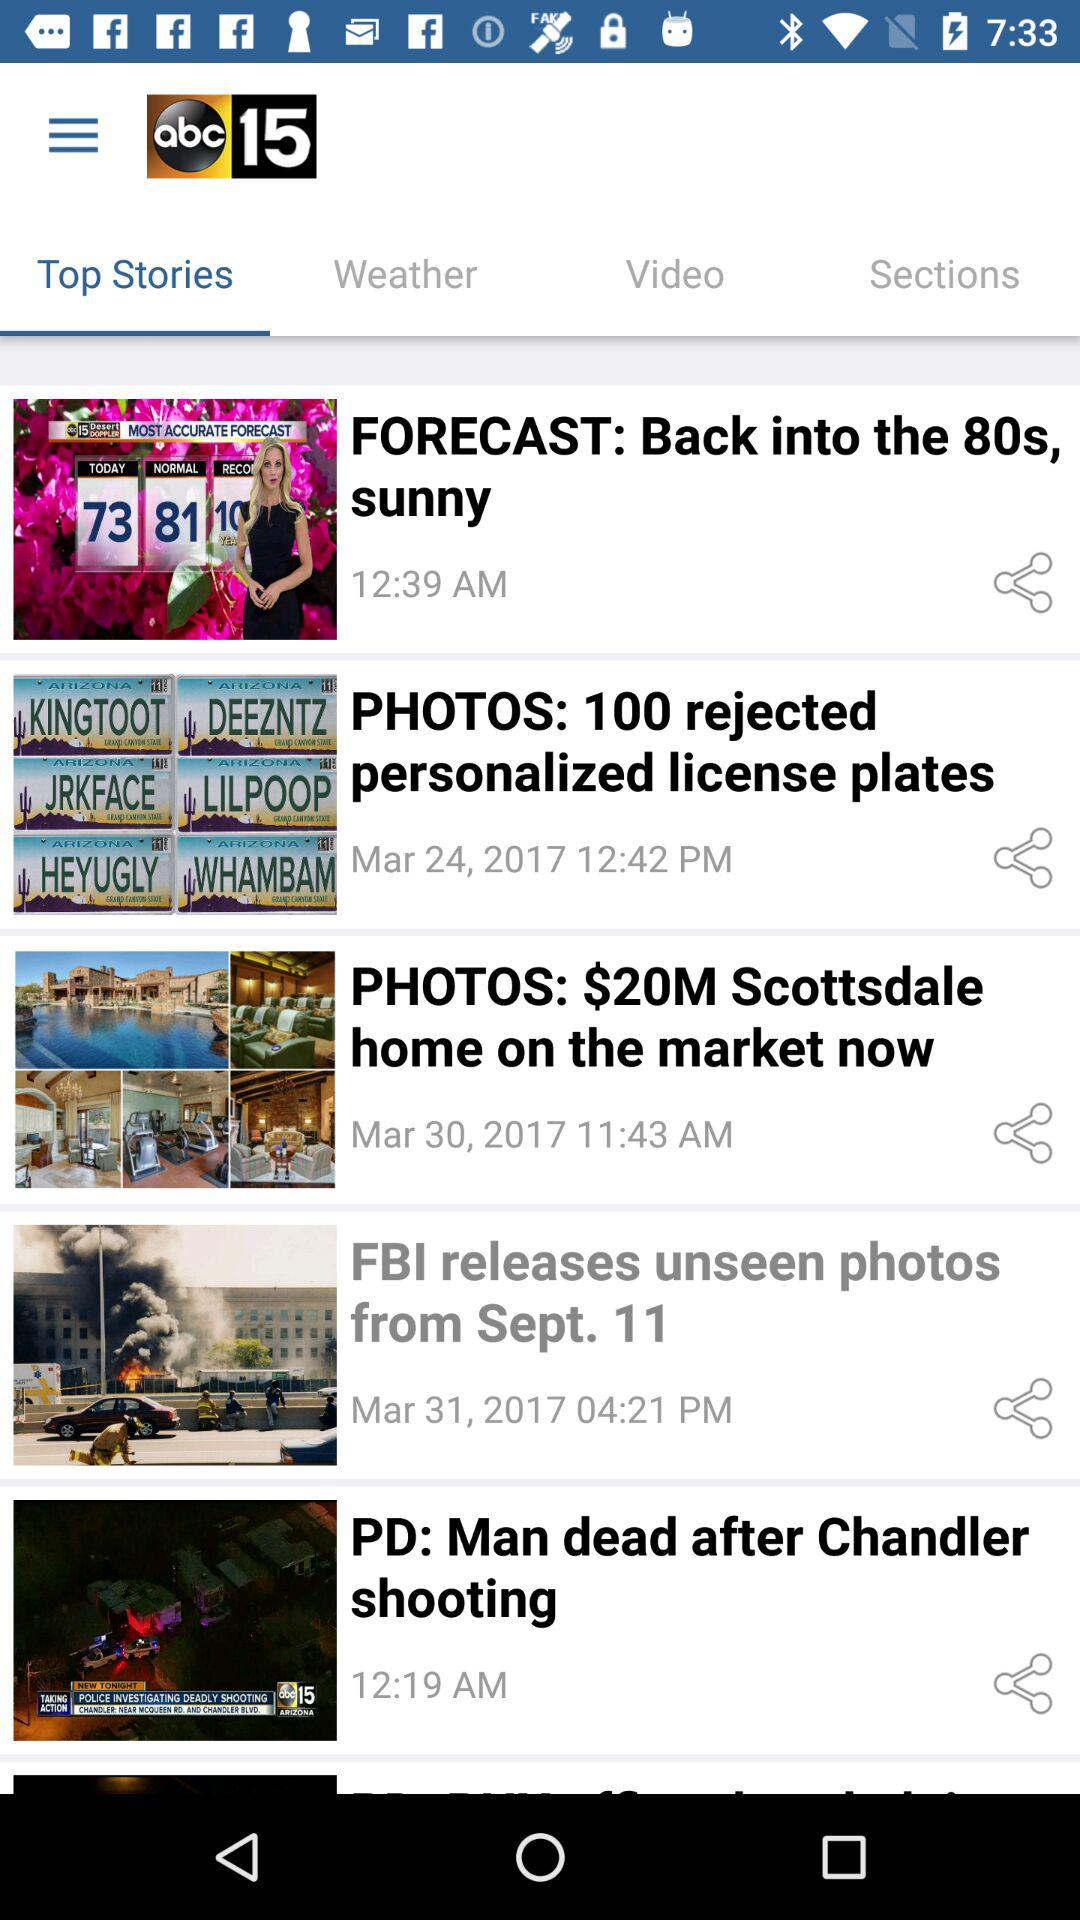What is the name of the application? The name of the application is "abc15". 